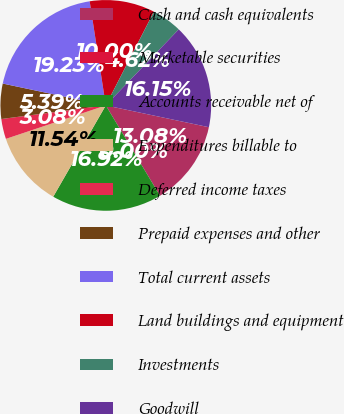<chart> <loc_0><loc_0><loc_500><loc_500><pie_chart><fcel>Cash and cash equivalents<fcel>Marketable securities<fcel>Accounts receivable net of<fcel>Expenditures billable to<fcel>Deferred income taxes<fcel>Prepaid expenses and other<fcel>Total current assets<fcel>Land buildings and equipment<fcel>Investments<fcel>Goodwill<nl><fcel>13.08%<fcel>0.0%<fcel>16.92%<fcel>11.54%<fcel>3.08%<fcel>5.39%<fcel>19.23%<fcel>10.0%<fcel>4.62%<fcel>16.15%<nl></chart> 